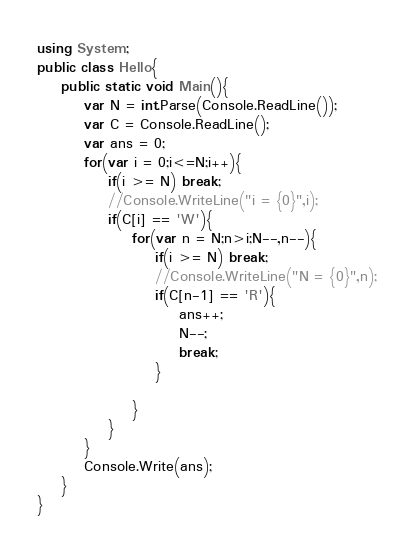<code> <loc_0><loc_0><loc_500><loc_500><_C#_>using System;
public class Hello{
    public static void Main(){
        var N = int.Parse(Console.ReadLine());
        var C = Console.ReadLine();
        var ans = 0;
        for(var i = 0;i<=N;i++){
            if(i >= N) break;
            //Console.WriteLine("i = {0}",i);
            if(C[i] == 'W'){
                for(var n = N;n>i;N--,n--){
                    if(i >= N) break;
                    //Console.WriteLine("N = {0}",n);
                    if(C[n-1] == 'R'){
                        ans++;
                        N--;
                        break;
                    }
                    
                }
            }
        }
        Console.Write(ans);
    }
}
</code> 